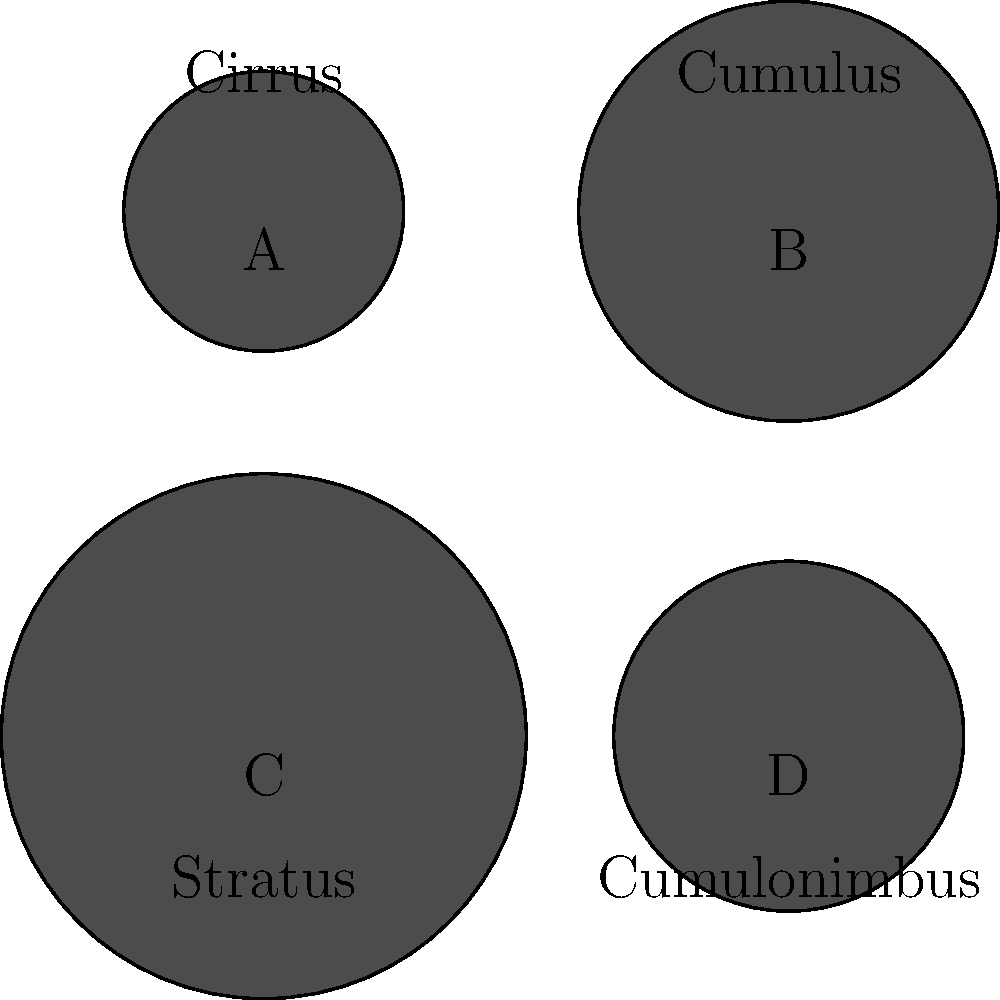As an FAA inspector, you're tasked with evaluating a pilot's knowledge of cloud types and their associated weather conditions. Based on the visual representations provided, which cloud type is most likely to be associated with severe thunderstorms and potential aviation hazards? To answer this question, we need to analyze each cloud type and its characteristics:

1. Cloud A (Cirrus): These are high-altitude, wispy clouds composed of ice crystals. They generally indicate fair weather and do not pose significant aviation hazards.

2. Cloud B (Cumulus): These are puffy, cotton-like clouds that form at low to middle altitudes. They often indicate fair weather but can develop into cumulonimbus clouds under certain conditions.

3. Cloud C (Stratus): These are low-lying, flat, and uniform clouds that can cover large areas. They may bring light precipitation but are not typically associated with severe weather.

4. Cloud D (Cumulonimbus): These are tall, dense clouds that extend from low to high altitudes. They are characterized by their anvil-like shape at the top.

Cumulonimbus clouds are associated with severe thunderstorms and pose significant aviation hazards, including:
- Strong updrafts and downdrafts
- Severe turbulence
- Lightning
- Heavy precipitation
- Potential for hail
- Icing conditions

Therefore, Cloud D (Cumulonimbus) is the correct answer, as it is most likely to be associated with severe thunderstorms and potential aviation hazards.
Answer: Cumulonimbus (Cloud D) 